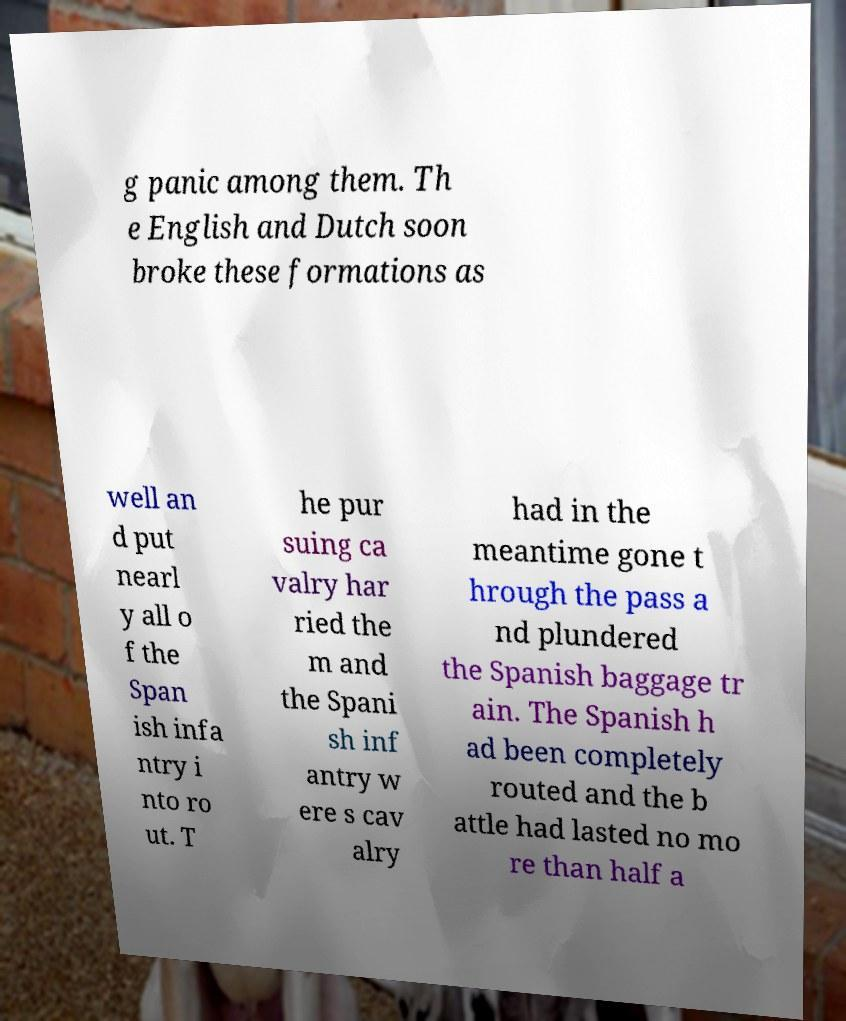For documentation purposes, I need the text within this image transcribed. Could you provide that? g panic among them. Th e English and Dutch soon broke these formations as well an d put nearl y all o f the Span ish infa ntry i nto ro ut. T he pur suing ca valry har ried the m and the Spani sh inf antry w ere s cav alry had in the meantime gone t hrough the pass a nd plundered the Spanish baggage tr ain. The Spanish h ad been completely routed and the b attle had lasted no mo re than half a 